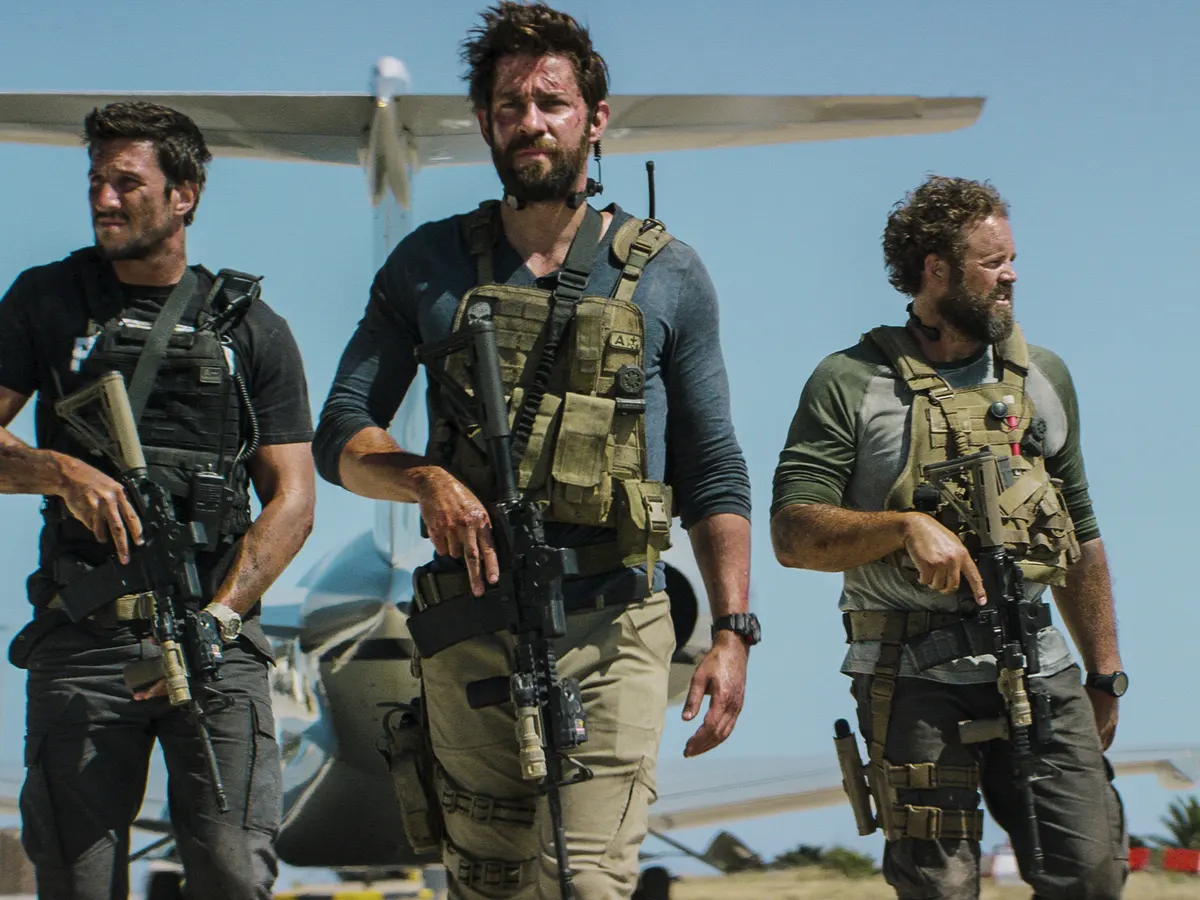How might the story of these characters evolve from here? The story could evolve in various thrilling directions. The trio might encounter unexpected resistance, leading to an intense firefight that tests their skills and camaraderie. They could uncover new intelligence that adds complexity to their mission, forcing them to adapt and overcome unforeseen challenges. Alternatively, the mission could be a rescue operation, and they might find themselves racing against time to save hostages from imminent danger. The evolving dynamics within the team, their backgrounds, and the high-stress environment would add depth and intrigue to their story, keeping the audience on the edge of their seats. Consider the perspectives of each individual in the image. What might be going through their minds? The central figure, with a look of determination, might be the team leader, focused on the mission's objective and the safety of his men. He could be strategizing the next steps and anticipating potential threats. The man on his left, slightly wary and scanning their surroundings, might be the team's scout or point man, constantly assessing risks and planning contingencies. The third individual, scanning to the side, might be the team's support, ensuring their flank is protected and ready to provide cover fire if needed. Each individual plays a critical role, their thoughts a blend of strategy, vigilance, and trust in their teammates. 